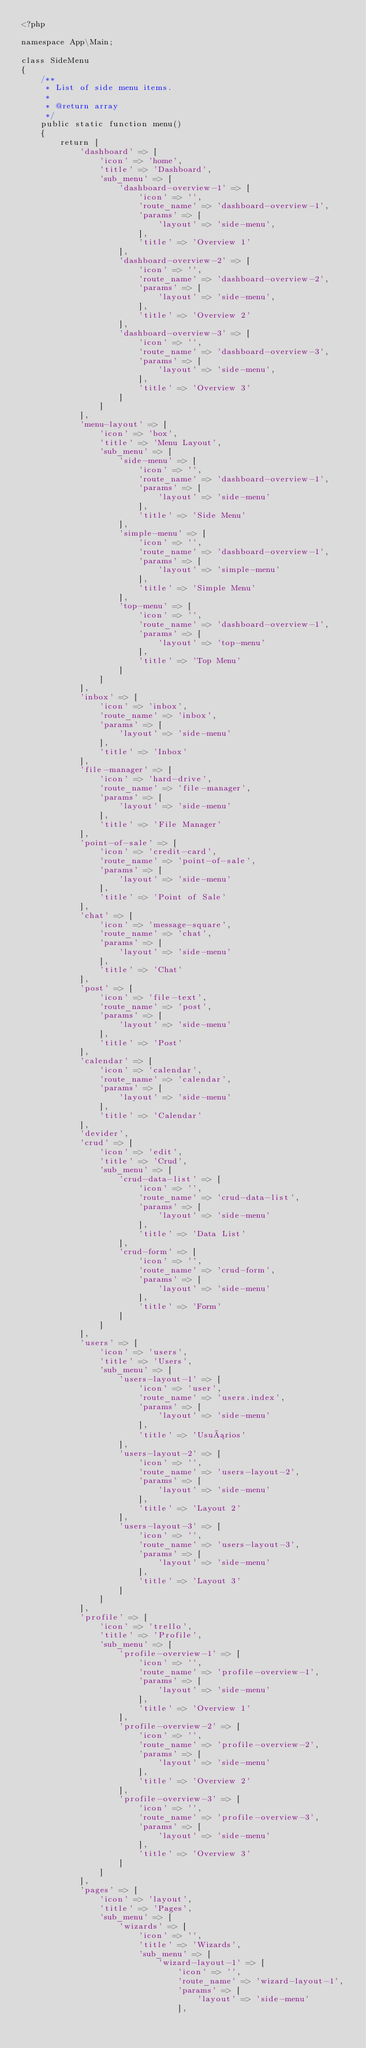Convert code to text. <code><loc_0><loc_0><loc_500><loc_500><_PHP_><?php

namespace App\Main;

class SideMenu
{
    /**
     * List of side menu items.
     *
     * @return array
     */
    public static function menu()
    {
        return [
            'dashboard' => [
                'icon' => 'home',
                'title' => 'Dashboard',
                'sub_menu' => [
                    'dashboard-overview-1' => [
                        'icon' => '',
                        'route_name' => 'dashboard-overview-1',
                        'params' => [
                            'layout' => 'side-menu',
                        ],
                        'title' => 'Overview 1'
                    ],
                    'dashboard-overview-2' => [
                        'icon' => '',
                        'route_name' => 'dashboard-overview-2',
                        'params' => [
                            'layout' => 'side-menu',
                        ],
                        'title' => 'Overview 2'
                    ],
                    'dashboard-overview-3' => [
                        'icon' => '',
                        'route_name' => 'dashboard-overview-3',
                        'params' => [
                            'layout' => 'side-menu',
                        ],
                        'title' => 'Overview 3'
                    ]
                ]
            ],
            'menu-layout' => [
                'icon' => 'box',
                'title' => 'Menu Layout',
                'sub_menu' => [
                    'side-menu' => [
                        'icon' => '',
                        'route_name' => 'dashboard-overview-1',
                        'params' => [
                            'layout' => 'side-menu'
                        ],
                        'title' => 'Side Menu'
                    ],
                    'simple-menu' => [
                        'icon' => '',
                        'route_name' => 'dashboard-overview-1',
                        'params' => [
                            'layout' => 'simple-menu'
                        ],
                        'title' => 'Simple Menu'
                    ],
                    'top-menu' => [
                        'icon' => '',
                        'route_name' => 'dashboard-overview-1',
                        'params' => [
                            'layout' => 'top-menu'
                        ],
                        'title' => 'Top Menu'
                    ]
                ]
            ],
            'inbox' => [
                'icon' => 'inbox',
                'route_name' => 'inbox',
                'params' => [
                    'layout' => 'side-menu'
                ],
                'title' => 'Inbox'
            ],
            'file-manager' => [
                'icon' => 'hard-drive',
                'route_name' => 'file-manager',
                'params' => [
                    'layout' => 'side-menu'
                ],
                'title' => 'File Manager'
            ],
            'point-of-sale' => [
                'icon' => 'credit-card',
                'route_name' => 'point-of-sale',
                'params' => [
                    'layout' => 'side-menu'
                ],
                'title' => 'Point of Sale'
            ],
            'chat' => [
                'icon' => 'message-square',
                'route_name' => 'chat',
                'params' => [
                    'layout' => 'side-menu'
                ],
                'title' => 'Chat'
            ],
            'post' => [
                'icon' => 'file-text',
                'route_name' => 'post',
                'params' => [
                    'layout' => 'side-menu'
                ],
                'title' => 'Post'
            ],
            'calendar' => [
                'icon' => 'calendar',
                'route_name' => 'calendar',
                'params' => [
                    'layout' => 'side-menu'
                ],
                'title' => 'Calendar'
            ],
            'devider',
            'crud' => [
                'icon' => 'edit',
                'title' => 'Crud',
                'sub_menu' => [
                    'crud-data-list' => [
                        'icon' => '',
                        'route_name' => 'crud-data-list',
                        'params' => [
                            'layout' => 'side-menu'
                        ],
                        'title' => 'Data List'
                    ],
                    'crud-form' => [
                        'icon' => '',
                        'route_name' => 'crud-form',
                        'params' => [
                            'layout' => 'side-menu'
                        ],
                        'title' => 'Form'
                    ]
                ]
            ],
            'users' => [
                'icon' => 'users',
                'title' => 'Users',
                'sub_menu' => [
                    'users-layout-1' => [
                        'icon' => 'user',
                        'route_name' => 'users.index',
                        'params' => [
                            'layout' => 'side-menu'
                        ],
                        'title' => 'Usuários'
                    ],
                    'users-layout-2' => [
                        'icon' => '',
                        'route_name' => 'users-layout-2',
                        'params' => [
                            'layout' => 'side-menu'
                        ],
                        'title' => 'Layout 2'
                    ],
                    'users-layout-3' => [
                        'icon' => '',
                        'route_name' => 'users-layout-3',
                        'params' => [
                            'layout' => 'side-menu'
                        ],
                        'title' => 'Layout 3'
                    ]
                ]
            ],
            'profile' => [
                'icon' => 'trello',
                'title' => 'Profile',
                'sub_menu' => [
                    'profile-overview-1' => [
                        'icon' => '',
                        'route_name' => 'profile-overview-1',
                        'params' => [
                            'layout' => 'side-menu'
                        ],
                        'title' => 'Overview 1'
                    ],
                    'profile-overview-2' => [
                        'icon' => '',
                        'route_name' => 'profile-overview-2',
                        'params' => [
                            'layout' => 'side-menu'
                        ],
                        'title' => 'Overview 2'
                    ],
                    'profile-overview-3' => [
                        'icon' => '',
                        'route_name' => 'profile-overview-3',
                        'params' => [
                            'layout' => 'side-menu'
                        ],
                        'title' => 'Overview 3'
                    ]
                ]
            ],
            'pages' => [
                'icon' => 'layout',
                'title' => 'Pages',
                'sub_menu' => [
                    'wizards' => [
                        'icon' => '',
                        'title' => 'Wizards',
                        'sub_menu' => [
                            'wizard-layout-1' => [
                                'icon' => '',
                                'route_name' => 'wizard-layout-1',
                                'params' => [
                                    'layout' => 'side-menu'
                                ],</code> 